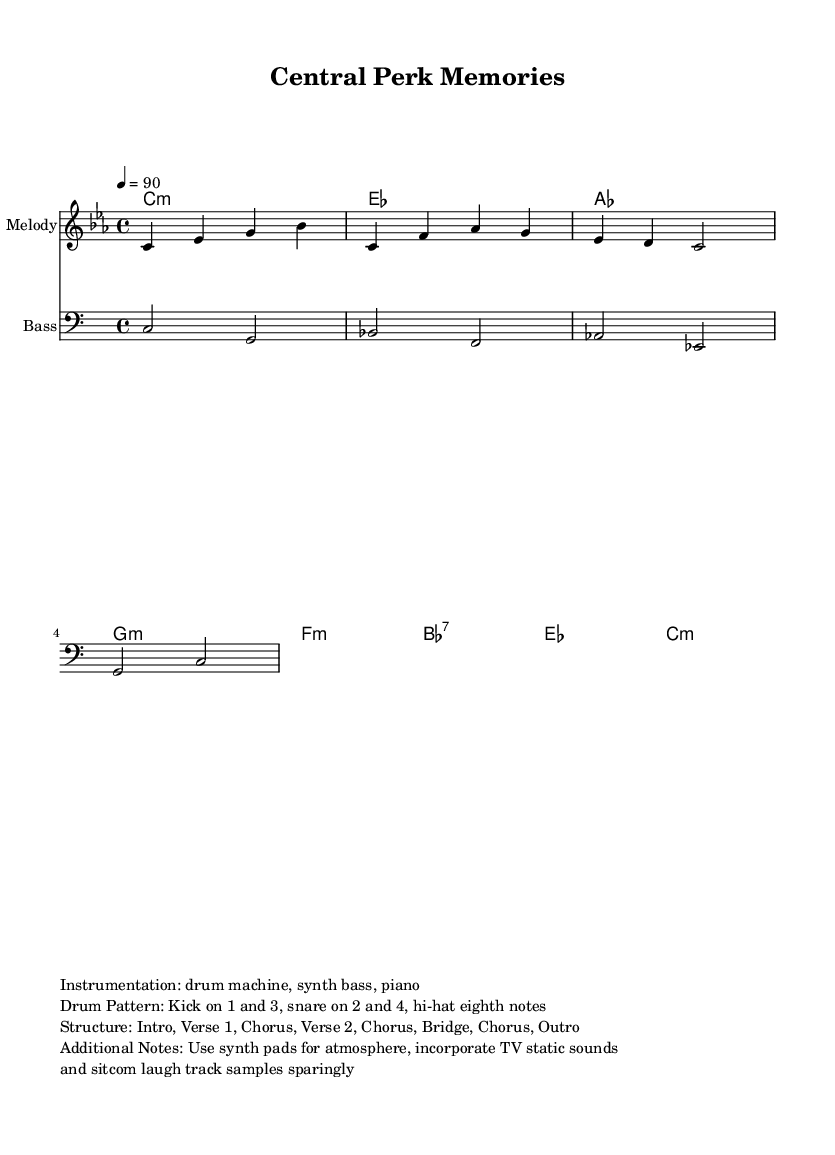What is the key signature of this music? The key signature is C minor, which has three flats (B flat, E flat, and A flat). This is derived from the global context in the sheet music, where "C minor" is specified.
Answer: C minor What is the time signature of this music? The time signature is 4/4, which indicates that there are four beats in each measure and the quarter note gets one beat. This can be found in the global section of the sheet music.
Answer: 4/4 What is the tempo marking given in the music? The tempo marking is 90, which indicates the speed of the music. In the global section, it specifies "4 = 90", meaning there are 90 beats per minute.
Answer: 90 How many measures are in the melody? There are three measures in the melody part as presented in the melodic section. Each line contains one measure, totaling three lines or measures.
Answer: Three What is the instrumentation used in this piece? The instrumentation listed specifies a drum machine, synth bass, and piano which set the overall vibe for the rap-style piece. This information can be found in the markup section of the music sheet.
Answer: Drum machine, synth bass, piano What type of sounds are incorporated into the music? The music includes TV static sounds and sitcom laugh track samples, which are meant to enhance the nostalgic vibe of the rap. This is mentioned specifically in the additional notes of the markup section.
Answer: TV static sounds, laugh track samples What chord is played for the first measure of the bass line? The first measure of the bass line plays the chord C, as indicated in the chord names section corresponding to the first measure.
Answer: C 